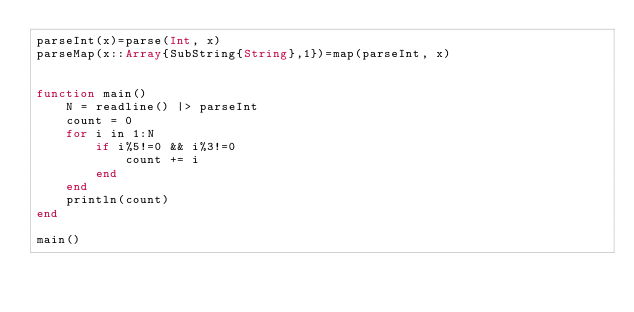<code> <loc_0><loc_0><loc_500><loc_500><_Julia_>parseInt(x)=parse(Int, x)
parseMap(x::Array{SubString{String},1})=map(parseInt, x)


function main()
    N = readline() |> parseInt
    count = 0
    for i in 1:N
        if i%5!=0 && i%3!=0
            count += i
        end
    end
    println(count)
end

main()</code> 